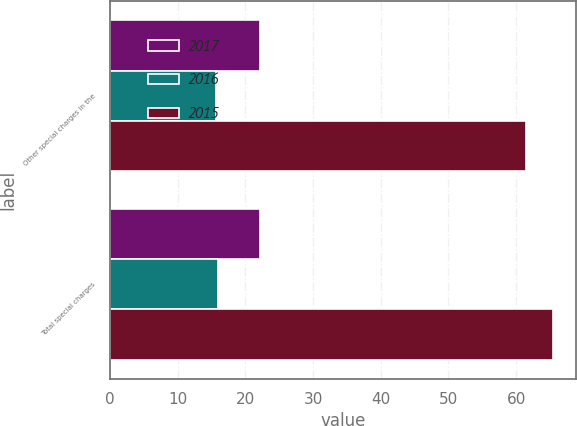Convert chart to OTSL. <chart><loc_0><loc_0><loc_500><loc_500><stacked_bar_chart><ecel><fcel>Other special charges in the<fcel>Total special charges<nl><fcel>2017<fcel>22.2<fcel>22.2<nl><fcel>2016<fcel>15.7<fcel>16<nl><fcel>2015<fcel>61.5<fcel>65.5<nl></chart> 